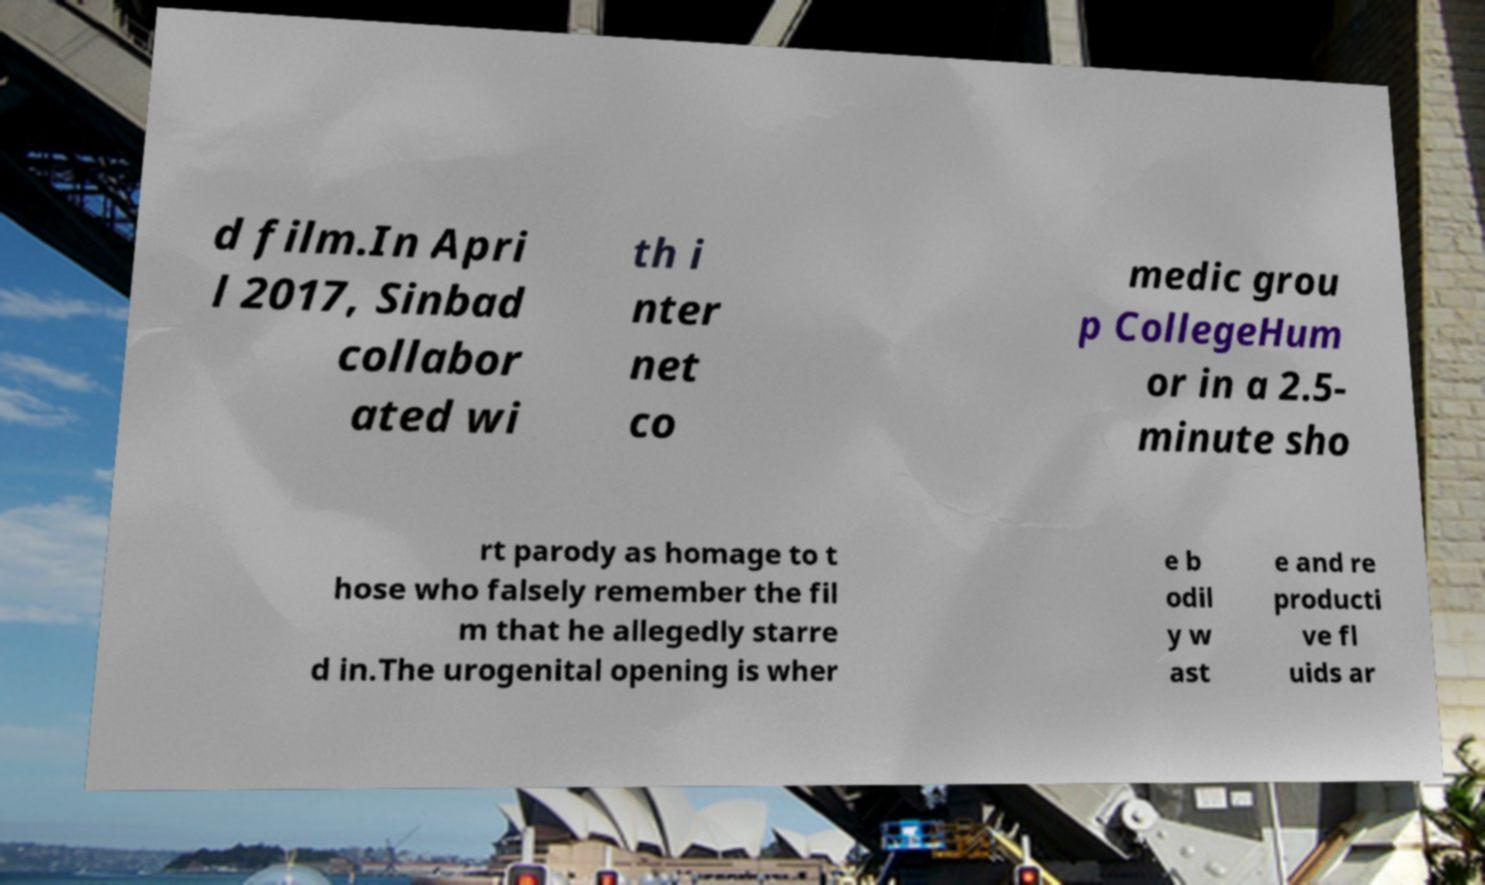What messages or text are displayed in this image? I need them in a readable, typed format. d film.In Apri l 2017, Sinbad collabor ated wi th i nter net co medic grou p CollegeHum or in a 2.5- minute sho rt parody as homage to t hose who falsely remember the fil m that he allegedly starre d in.The urogenital opening is wher e b odil y w ast e and re producti ve fl uids ar 